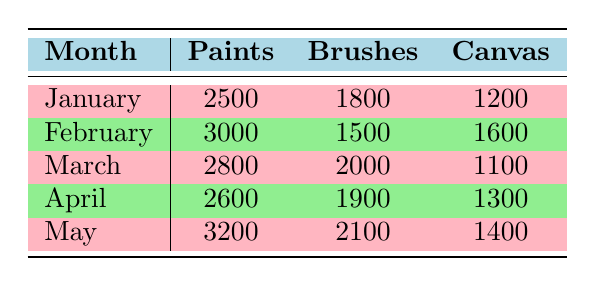What were the total sales of Canvas in February? The sales of Canvas in February is listed as 1600 in the table. There is no need for additional calculations since we are only retrieving a specific value.
Answer: 1600 Which category had the highest sales in January? In January, the table shows Paints with sales of 2500, Brushes with 1800, and Canvas with 1200. Paints has the highest sales.
Answer: Paints What is the difference in Paint sales between February and March? February sales for Paints are 3000 and for March they are 2800. The difference is calculated as 3000 - 2800 = 200.
Answer: 200 Is the sales figure for Brushes in April greater than 1900? The sales for Brushes in April is 1900 as per the table. Since the value is not greater than 1900, the answer is false.
Answer: No What was the average sales of all categories in March? The sales figures for March are Paints (2800), Brushes (2000), and Canvas (1100). The average is calculated as (2800 + 2000 + 1100) / 3 = 2000.
Answer: 2000 Which month had the lowest sales for Canvas, and what was the amount? The Canvas sales across months are: January (1200), February (1600), March (1100), April (1300), and May (1400). March has the lowest sales at 1100.
Answer: March, 1100 If we combine the sales of Brushes in January and May, what is the total? The sales for Brushes in January is 1800, and in May it is 2100. The total is calculated as 1800 + 2100 = 3900.
Answer: 3900 Did the sales of Paints increase every month from January to May? The sales figures for Paints are: January (2500), February (3000), March (2800), April (2600), and May (3200). They did not increase every month since there were decreases in March and April.
Answer: No In which month did Canvas experience the highest sales, and what was that value? The month-by-month sales for Canvas are: January (1200), February (1600), March (1100), April (1300), and May (1400). February shows the highest sales at 1600.
Answer: February, 1600 